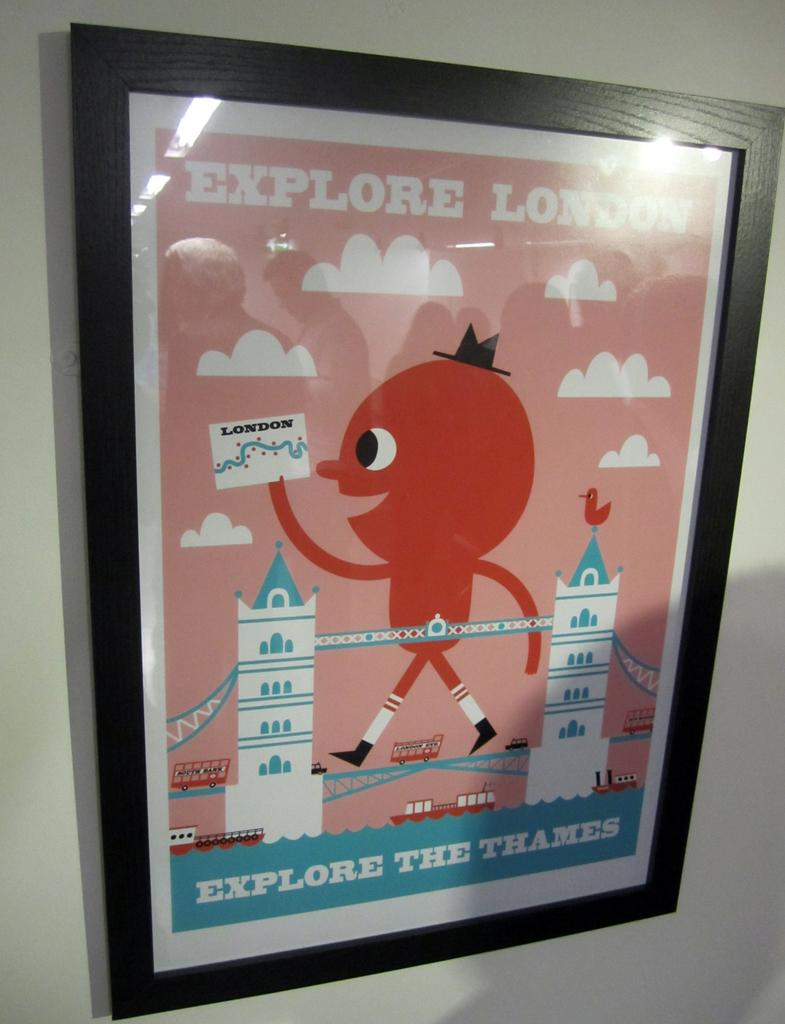<image>
Share a concise interpretation of the image provided. a poster in a frame that says 'explore the thames' on it 